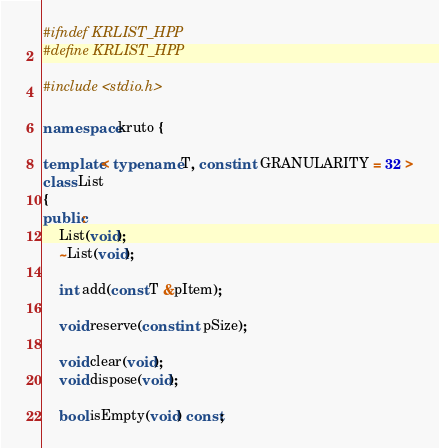Convert code to text. <code><loc_0><loc_0><loc_500><loc_500><_C++_>#ifndef KRLIST_HPP
#define KRLIST_HPP

#include <stdio.h>

namespace kruto {

template< typename T, const int GRANULARITY = 32 >
class List
{
public:
	List(void);
	~List(void);

	int add(const T &pItem);

	void reserve(const int pSize);

	void clear(void);
	void dispose(void);

	bool isEmpty(void) const;</code> 